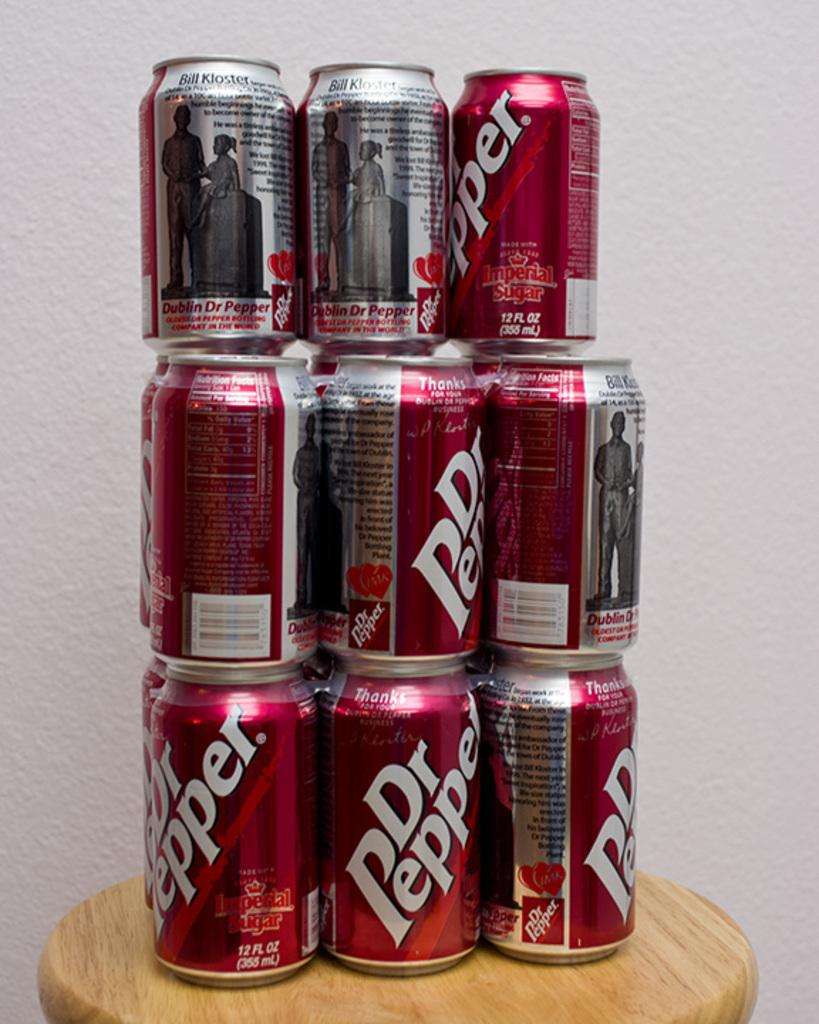<image>
Create a compact narrative representing the image presented. A stack of Dr Pepper cans that are on a wooden stool. 